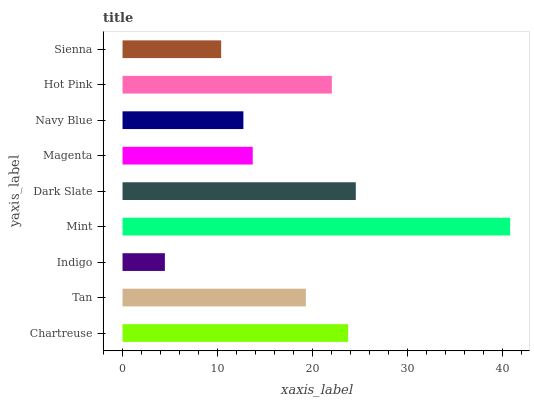Is Indigo the minimum?
Answer yes or no. Yes. Is Mint the maximum?
Answer yes or no. Yes. Is Tan the minimum?
Answer yes or no. No. Is Tan the maximum?
Answer yes or no. No. Is Chartreuse greater than Tan?
Answer yes or no. Yes. Is Tan less than Chartreuse?
Answer yes or no. Yes. Is Tan greater than Chartreuse?
Answer yes or no. No. Is Chartreuse less than Tan?
Answer yes or no. No. Is Tan the high median?
Answer yes or no. Yes. Is Tan the low median?
Answer yes or no. Yes. Is Hot Pink the high median?
Answer yes or no. No. Is Magenta the low median?
Answer yes or no. No. 